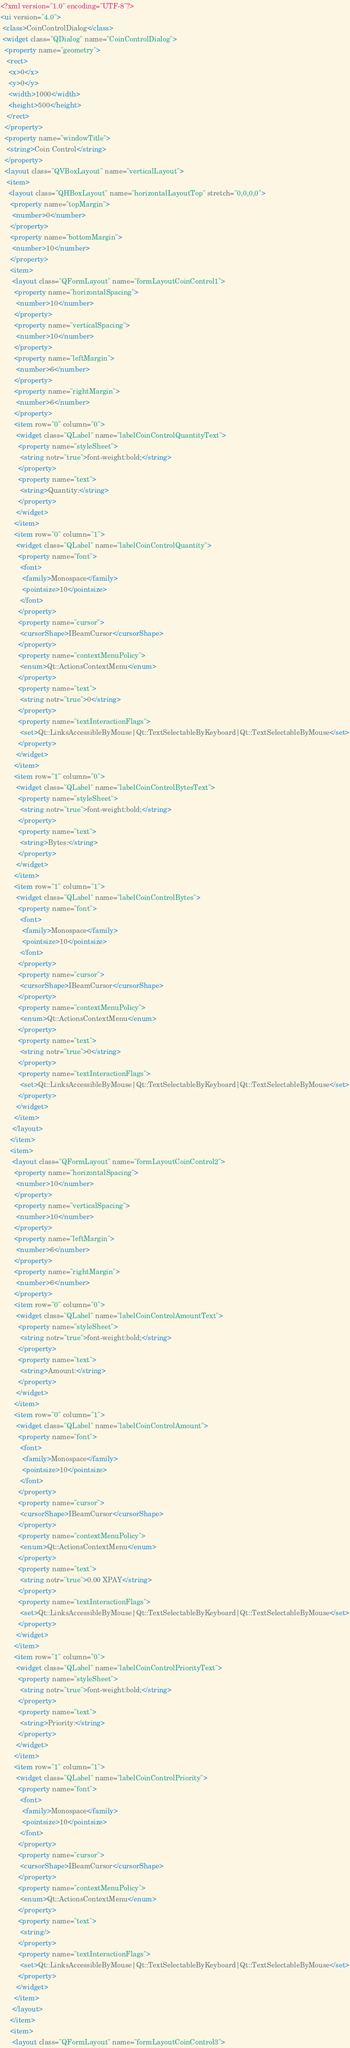Convert code to text. <code><loc_0><loc_0><loc_500><loc_500><_XML_><?xml version="1.0" encoding="UTF-8"?>
<ui version="4.0">
 <class>CoinControlDialog</class>
 <widget class="QDialog" name="CoinControlDialog">
  <property name="geometry">
   <rect>
    <x>0</x>
    <y>0</y>
    <width>1000</width>
    <height>500</height>
   </rect>
  </property>
  <property name="windowTitle">
   <string>Coin Control</string>
  </property>
  <layout class="QVBoxLayout" name="verticalLayout">
   <item>
    <layout class="QHBoxLayout" name="horizontalLayoutTop" stretch="0,0,0,0">
     <property name="topMargin">
      <number>0</number>
     </property>
     <property name="bottomMargin">
      <number>10</number>
     </property>
     <item>
      <layout class="QFormLayout" name="formLayoutCoinControl1">
       <property name="horizontalSpacing">
        <number>10</number>
       </property>
       <property name="verticalSpacing">
        <number>10</number>
       </property>
       <property name="leftMargin">
        <number>6</number>
       </property>
       <property name="rightMargin">
        <number>6</number>
       </property>
       <item row="0" column="0">
        <widget class="QLabel" name="labelCoinControlQuantityText">
         <property name="styleSheet">
          <string notr="true">font-weight:bold;</string>
         </property>
         <property name="text">
          <string>Quantity:</string>
         </property>
        </widget>
       </item>
       <item row="0" column="1">
        <widget class="QLabel" name="labelCoinControlQuantity">
         <property name="font">
          <font>
           <family>Monospace</family>
           <pointsize>10</pointsize>
          </font>
         </property>
         <property name="cursor">
          <cursorShape>IBeamCursor</cursorShape>
         </property>
         <property name="contextMenuPolicy">
          <enum>Qt::ActionsContextMenu</enum>
         </property>
         <property name="text">
          <string notr="true">0</string>
         </property>
         <property name="textInteractionFlags">
          <set>Qt::LinksAccessibleByMouse|Qt::TextSelectableByKeyboard|Qt::TextSelectableByMouse</set>
         </property>
        </widget>
       </item>
       <item row="1" column="0">
        <widget class="QLabel" name="labelCoinControlBytesText">
         <property name="styleSheet">
          <string notr="true">font-weight:bold;</string>
         </property>
         <property name="text">
          <string>Bytes:</string>
         </property>
        </widget>
       </item>
       <item row="1" column="1">
        <widget class="QLabel" name="labelCoinControlBytes">
         <property name="font">
          <font>
           <family>Monospace</family>
           <pointsize>10</pointsize>
          </font>
         </property>
         <property name="cursor">
          <cursorShape>IBeamCursor</cursorShape>
         </property>
         <property name="contextMenuPolicy">
          <enum>Qt::ActionsContextMenu</enum>
         </property>
         <property name="text">
          <string notr="true">0</string>
         </property>
         <property name="textInteractionFlags">
          <set>Qt::LinksAccessibleByMouse|Qt::TextSelectableByKeyboard|Qt::TextSelectableByMouse</set>
         </property>
        </widget>
       </item>
      </layout>
     </item>
     <item>
      <layout class="QFormLayout" name="formLayoutCoinControl2">
       <property name="horizontalSpacing">
        <number>10</number>
       </property>
       <property name="verticalSpacing">
        <number>10</number>
       </property>
       <property name="leftMargin">
        <number>6</number>
       </property>
       <property name="rightMargin">
        <number>6</number>
       </property>
       <item row="0" column="0">
        <widget class="QLabel" name="labelCoinControlAmountText">
         <property name="styleSheet">
          <string notr="true">font-weight:bold;</string>
         </property>
         <property name="text">
          <string>Amount:</string>
         </property>
        </widget>
       </item>
       <item row="0" column="1">
        <widget class="QLabel" name="labelCoinControlAmount">
         <property name="font">
          <font>
           <family>Monospace</family>
           <pointsize>10</pointsize>
          </font>
         </property>
         <property name="cursor">
          <cursorShape>IBeamCursor</cursorShape>
         </property>
         <property name="contextMenuPolicy">
          <enum>Qt::ActionsContextMenu</enum>
         </property>
         <property name="text">
          <string notr="true">0.00 XPAY</string>
         </property>
         <property name="textInteractionFlags">
          <set>Qt::LinksAccessibleByMouse|Qt::TextSelectableByKeyboard|Qt::TextSelectableByMouse</set>
         </property>
        </widget>
       </item>
       <item row="1" column="0">
        <widget class="QLabel" name="labelCoinControlPriorityText">
         <property name="styleSheet">
          <string notr="true">font-weight:bold;</string>
         </property>
         <property name="text">
          <string>Priority:</string>
         </property>
        </widget>
       </item>
       <item row="1" column="1">
        <widget class="QLabel" name="labelCoinControlPriority">
         <property name="font">
          <font>
           <family>Monospace</family>
           <pointsize>10</pointsize>
          </font>
         </property>
         <property name="cursor">
          <cursorShape>IBeamCursor</cursorShape>
         </property>
         <property name="contextMenuPolicy">
          <enum>Qt::ActionsContextMenu</enum>
         </property>
         <property name="text">
          <string/>
         </property>
         <property name="textInteractionFlags">
          <set>Qt::LinksAccessibleByMouse|Qt::TextSelectableByKeyboard|Qt::TextSelectableByMouse</set>
         </property>
        </widget>
       </item>
      </layout>
     </item>
     <item>
      <layout class="QFormLayout" name="formLayoutCoinControl3"></code> 